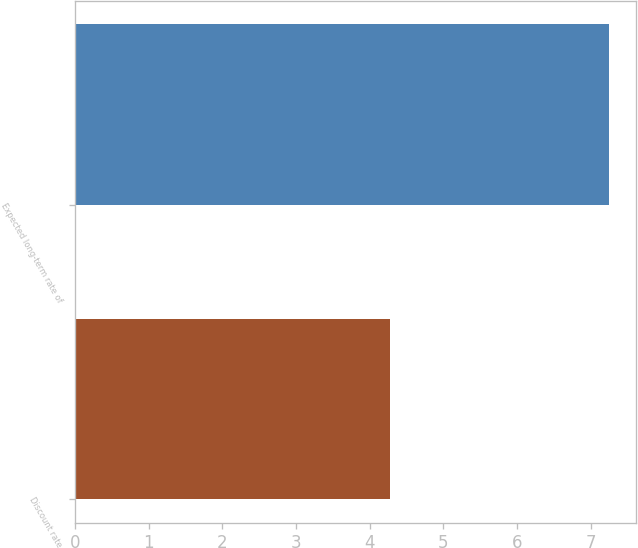Convert chart. <chart><loc_0><loc_0><loc_500><loc_500><bar_chart><fcel>Discount rate<fcel>Expected long-term rate of<nl><fcel>4.27<fcel>7.25<nl></chart> 